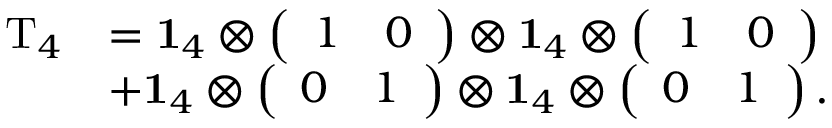<formula> <loc_0><loc_0><loc_500><loc_500>\begin{array} { r l } { T _ { 4 } } & { = 1 _ { 4 } \otimes \left ( \begin{array} { l l } { 1 } & { 0 } \end{array} \right ) \otimes 1 _ { 4 } \otimes \left ( \begin{array} { l l } { 1 } & { 0 } \end{array} \right ) } \\ & { + 1 _ { 4 } \otimes \left ( \begin{array} { l l } { 0 } & { 1 } \end{array} \right ) \otimes 1 _ { 4 } \otimes \left ( \begin{array} { l l } { 0 } & { 1 } \end{array} \right ) . } \end{array}</formula> 